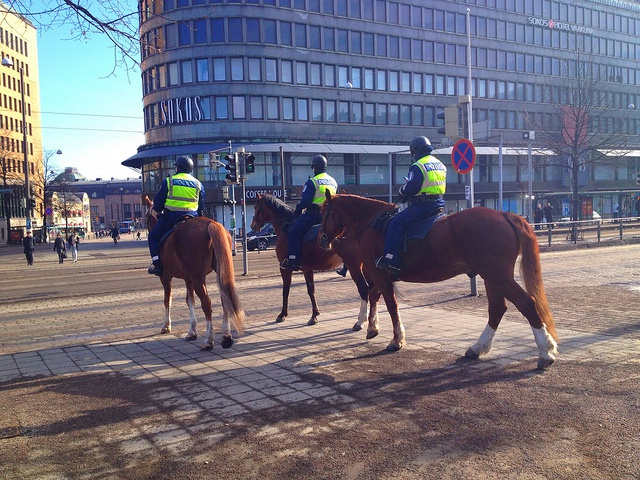Describe the objects in this image and their specific colors. I can see horse in lightblue, black, purple, and gray tones, horse in lightblue, black, gray, maroon, and brown tones, people in lightblue, navy, black, white, and gray tones, horse in lightblue, black, navy, maroon, and gray tones, and people in lightblue, black, navy, gray, and lime tones in this image. 